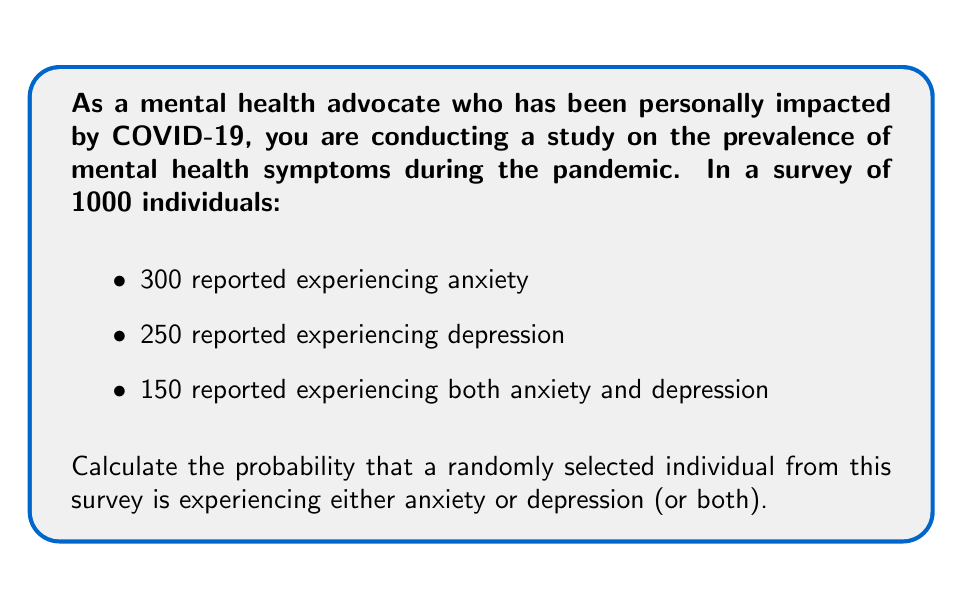Could you help me with this problem? To solve this problem, we'll use the concept of probability and set theory.

Let's define our events:
A = experiencing anxiety
D = experiencing depression

We're given:
- P(A) = 300/1000 = 0.3
- P(D) = 250/1000 = 0.25
- P(A ∩ D) = 150/1000 = 0.15 (intersection of A and D)

We want to find P(A ∪ D), which is the probability of experiencing either anxiety or depression or both.

We can use the addition rule of probability:

$$ P(A \cup D) = P(A) + P(D) - P(A \cap D) $$

This formula accounts for the overlap between A and D to avoid double-counting.

Substituting our values:

$$ P(A \cup D) = 0.3 + 0.25 - 0.15 $$

$$ P(A \cup D) = 0.55 - 0.15 $$

$$ P(A \cup D) = 0.4 $$

Therefore, the probability that a randomly selected individual from the survey is experiencing either anxiety or depression (or both) is 0.4 or 40%.
Answer: The probability is 0.4 or 40%. 